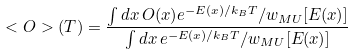<formula> <loc_0><loc_0><loc_500><loc_500>< O > ( T ) = \frac { \int d x \, O ( x ) e ^ { - E ( x ) / k _ { B } T } / w _ { M U } [ E ( x ) ] } { \int d x \, e ^ { - E ( x ) / k _ { B } T } / w _ { M U } [ E ( x ) ] }</formula> 